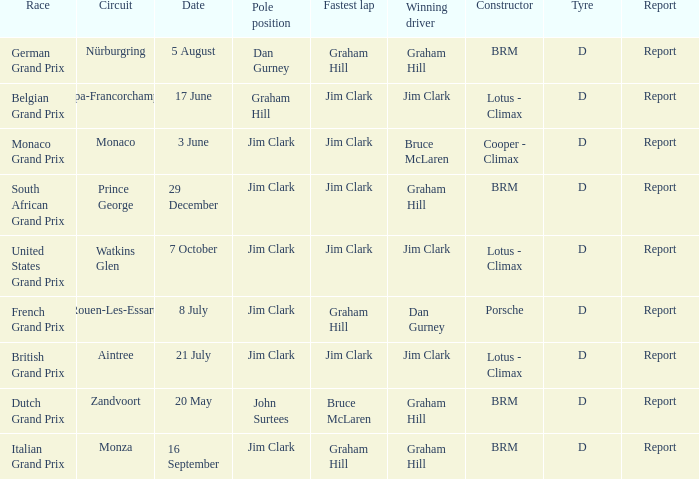What is the tyre for the circuit of Prince George, which had Jim Clark as the fastest lap? D. 